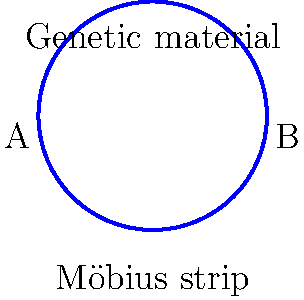In genetic crossover events, DNA strands twist and exchange genetic material. This process can be visualized using a Möbius strip, as shown in the diagram. If point A represents the start of a gene sequence and point B represents the end, how many times must you traverse the strip to cover both sides and return to the starting point? To understand this question, let's break it down step-by-step:

1. A Möbius strip is a surface with only one side and one edge. It's created by taking a strip of paper, giving it a half-twist, and then joining the ends.

2. In the context of genetic crossover, the Möbius strip can represent how DNA strands twist and exchange genetic material.

3. The key property of a Möbius strip is that if you start at any point and move along the surface, you will eventually return to your starting point having traversed the entire surface.

4. In a normal strip, you would need to go around twice to cover both sides. However, in a Möbius strip:
   - Starting at point A, you move along the strip.
   - As you move, you cover what seems to be one side.
   - When you reach point B, you're on what seems to be the opposite side.
   - Continuing from B back to A, you cover the "other side".
   - You arrive back at A having covered the entire surface.

5. This single traversal covers what would be both sides on a normal strip, representing how genetic material can be exchanged in a continuous process during crossover.

Therefore, you only need to traverse the Möbius strip once to cover both "sides" and return to the starting point.
Answer: Once 